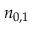<formula> <loc_0><loc_0><loc_500><loc_500>n _ { 0 , 1 }</formula> 